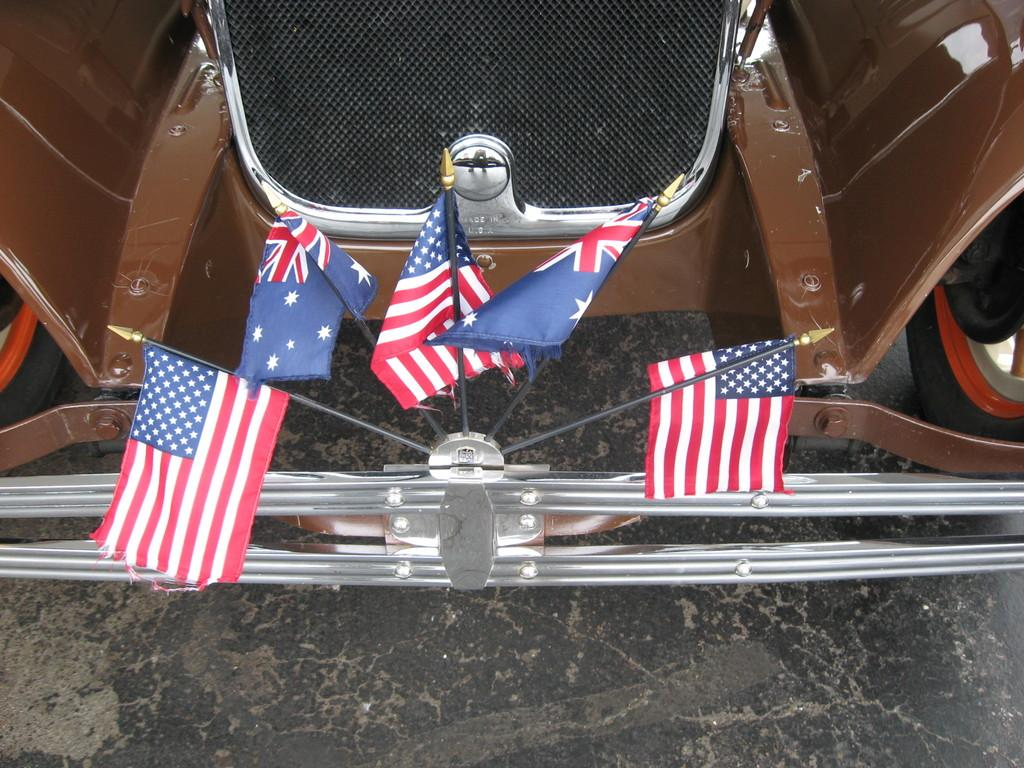What can be seen flying in the image? There are flags in the image. What type of vehicle is present in the image? There is a car in the image. What type of nerve can be seen in the image? There is no nerve present in the image. Can you describe the pickle that is sitting on the car in the image? There is no pickle present in the image. 